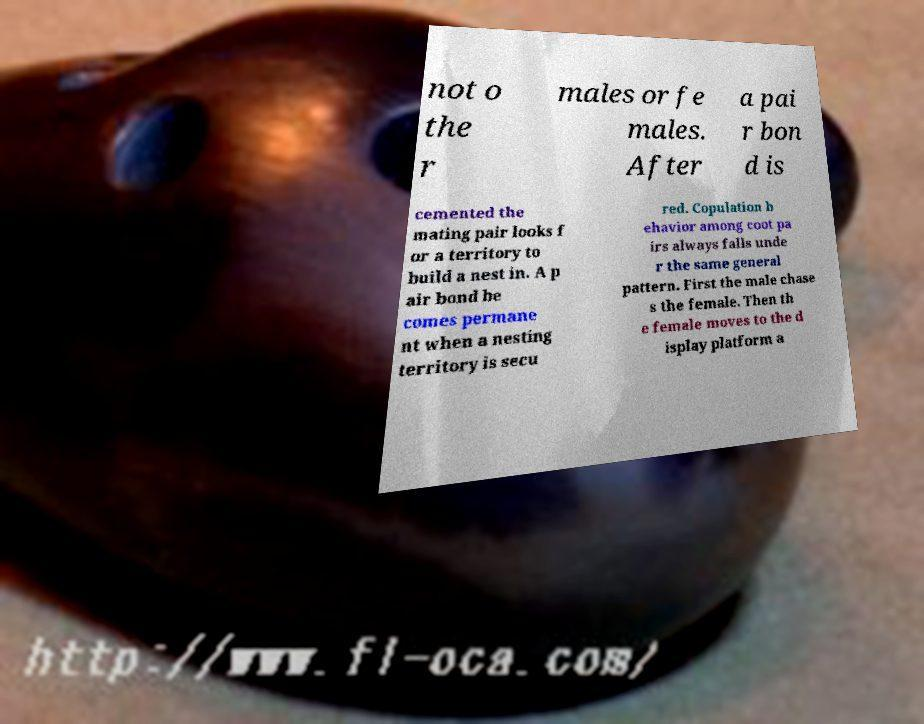I need the written content from this picture converted into text. Can you do that? not o the r males or fe males. After a pai r bon d is cemented the mating pair looks f or a territory to build a nest in. A p air bond be comes permane nt when a nesting territory is secu red. Copulation b ehavior among coot pa irs always falls unde r the same general pattern. First the male chase s the female. Then th e female moves to the d isplay platform a 